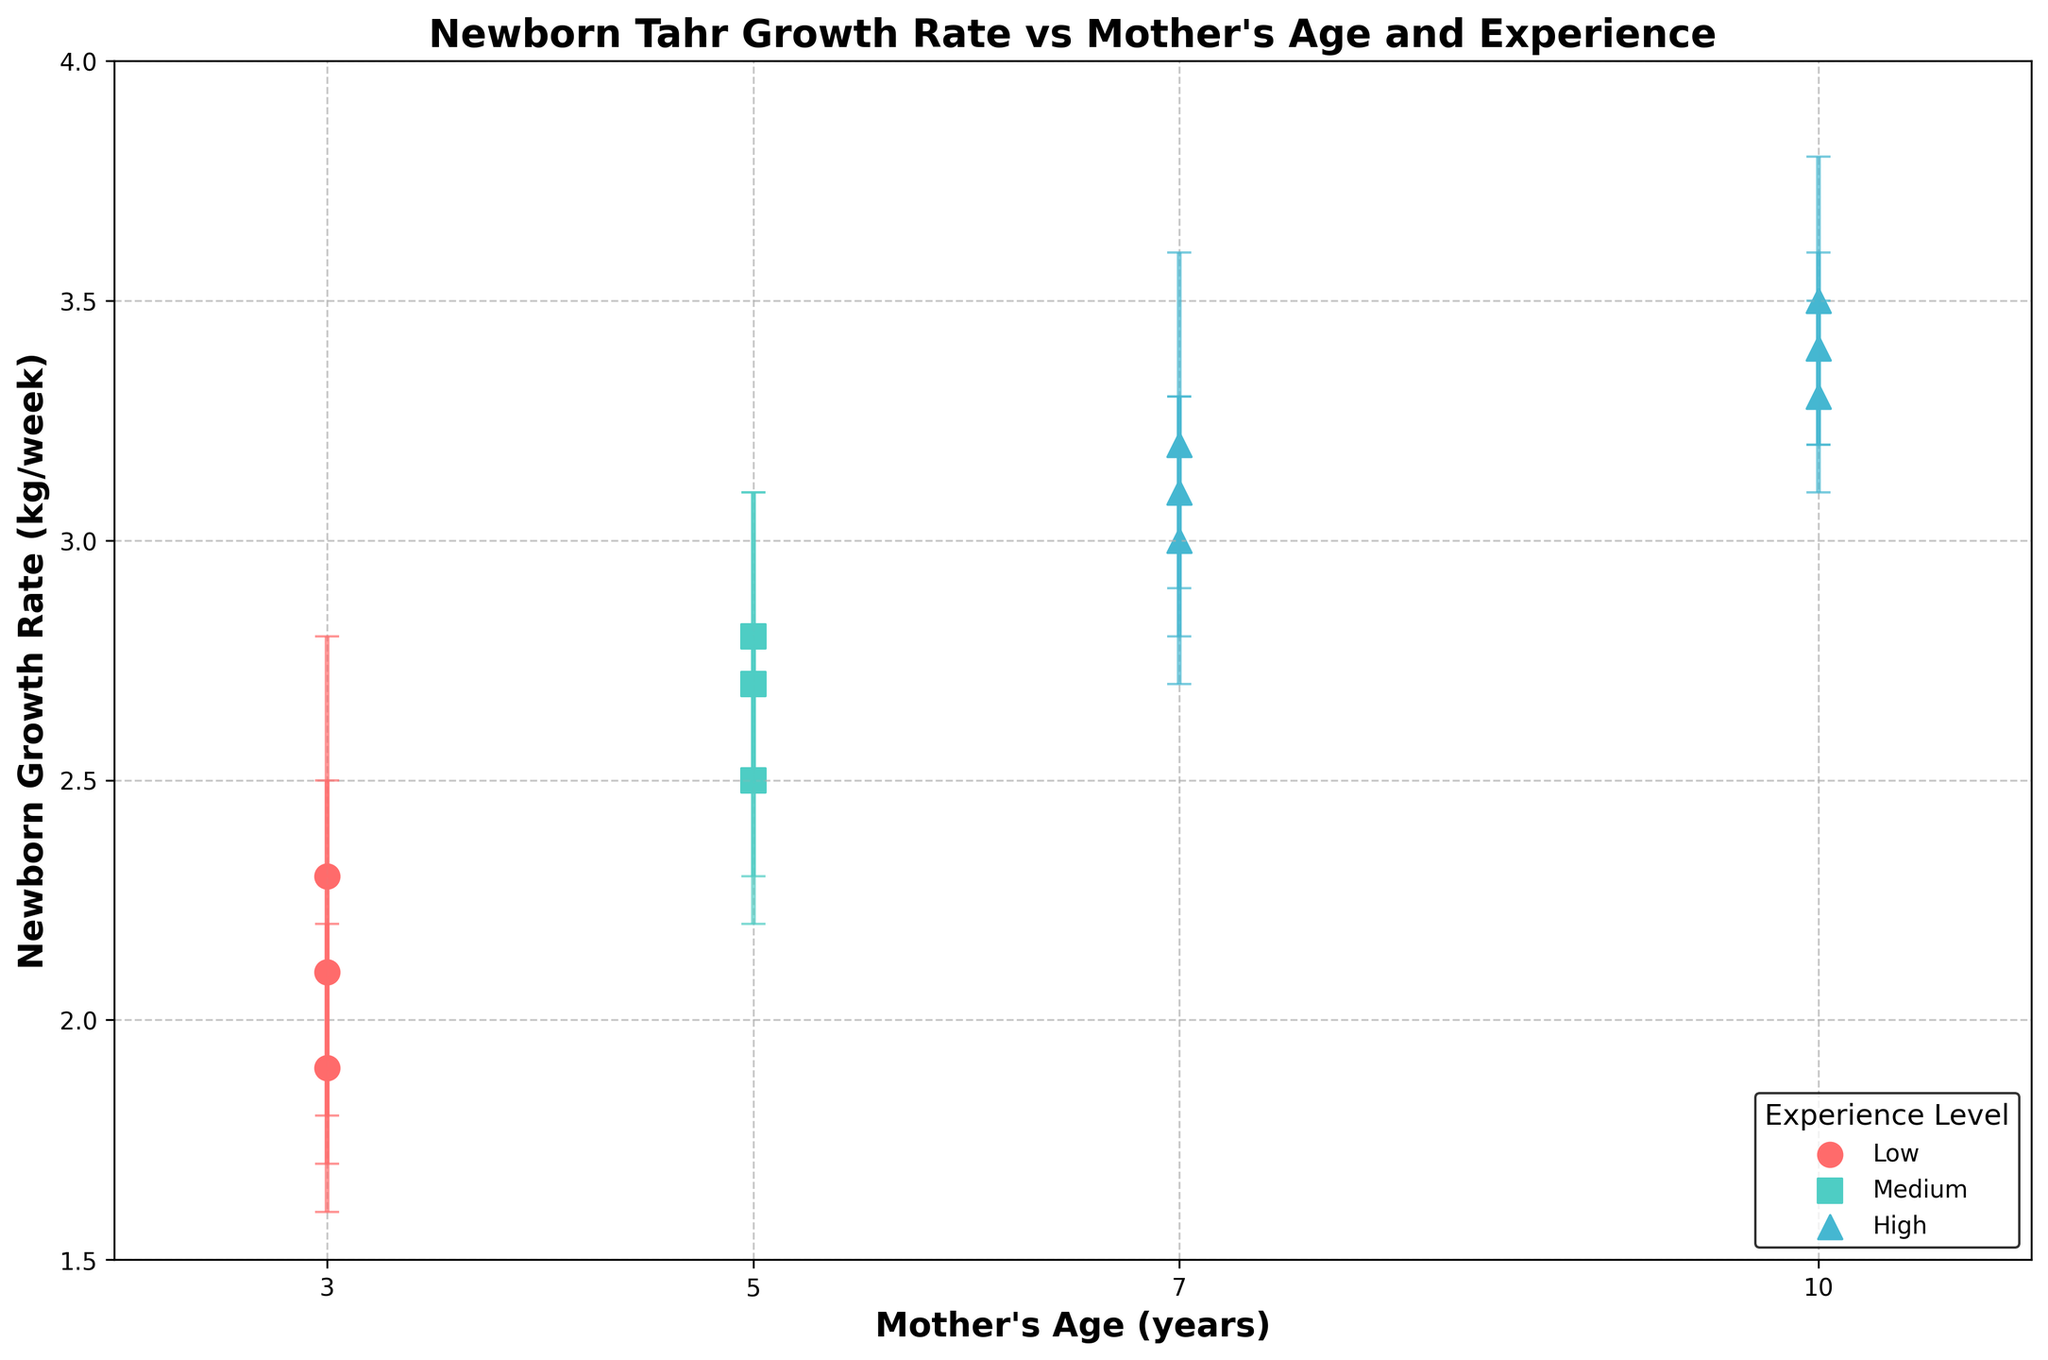What is the title of the figure? The title of the figure is usually displayed at the top. Here, the title is "Newborn Tahr Growth Rate vs Mother's Age and Experience".
Answer: Newborn Tahr Growth Rate vs Mother's Age and Experience What does the y-axis represent? The y-axis label is "Newborn Growth Rate (kg/week)", which tells us it represents the growth rate of the newborn Tahr in kilograms per week.
Answer: Newborn Growth Rate (kg/week) What color is used to represent the High experience level? By looking at the legend, High experience level is represented by a color. In this figure, the High experience level is marked with a blue color.
Answer: Blue What is the range of mother's age in years in the data? The x-axis represents the mother's age. The range can be observed from the lowest to the highest tick marks on the x-axis, which are 3 years to 10 years.
Answer: 3 to 10 years Which experience level shows the highest average newborn growth rate? To determine this, compare the average positions of the markers for each experience level. High experience level shows markers (7 and 10 years) that are mostly higher than those of Low and Medium experience levels.
Answer: High What is the approximate average growth rate for newborns of mothers aged 7 years with High experience? Average the values for the growth rates shown at mother age 7. This is (3.1 + 3.0 + 3.2) / 3 = approximately 3.1 kg/week.
Answer: 3.1 kg/week Is there a visible trend in the newborn growth rate in relation to the mother's age? By inspecting the scatter plot, there seems to be an increasing trend in the newborn growth rate as the mother's age increases from 3 to 10 years.
Answer: Increasing trend How does the error for mothers with High experience compare between ages 7 and 10? The error bars for mother age 7 are larger than those for mother age 10.
Answer: Larger at age 7 Which two experience levels have the smallest difference in average growth rates? By observing the positions of the markers and their averages, Medium and High experience levels appear to have the smallest difference in average growth rates.
Answer: Medium and High For mothers with Medium experience, what is the approximate range of the newborn growth rate? Observe the points representing Medium experience level. The rates range from around 2.5 to 2.8 kg/week.
Answer: 2.5 to 2.8 kg/week 